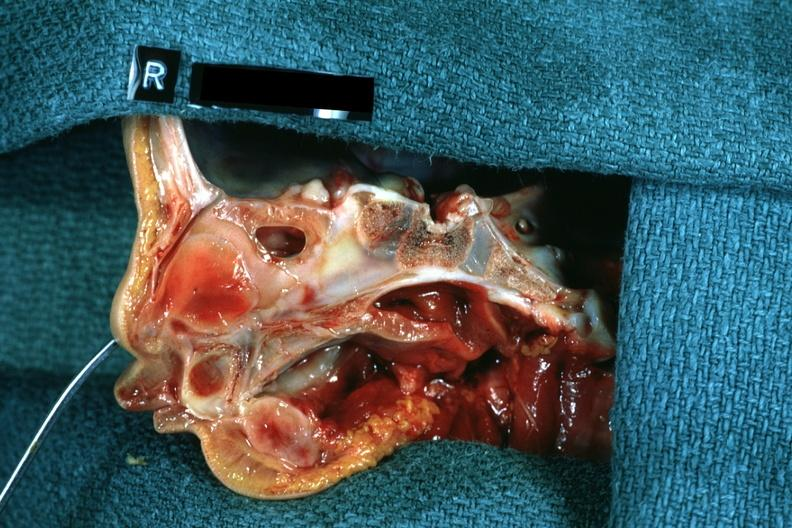s teeth present?
Answer the question using a single word or phrase. No 